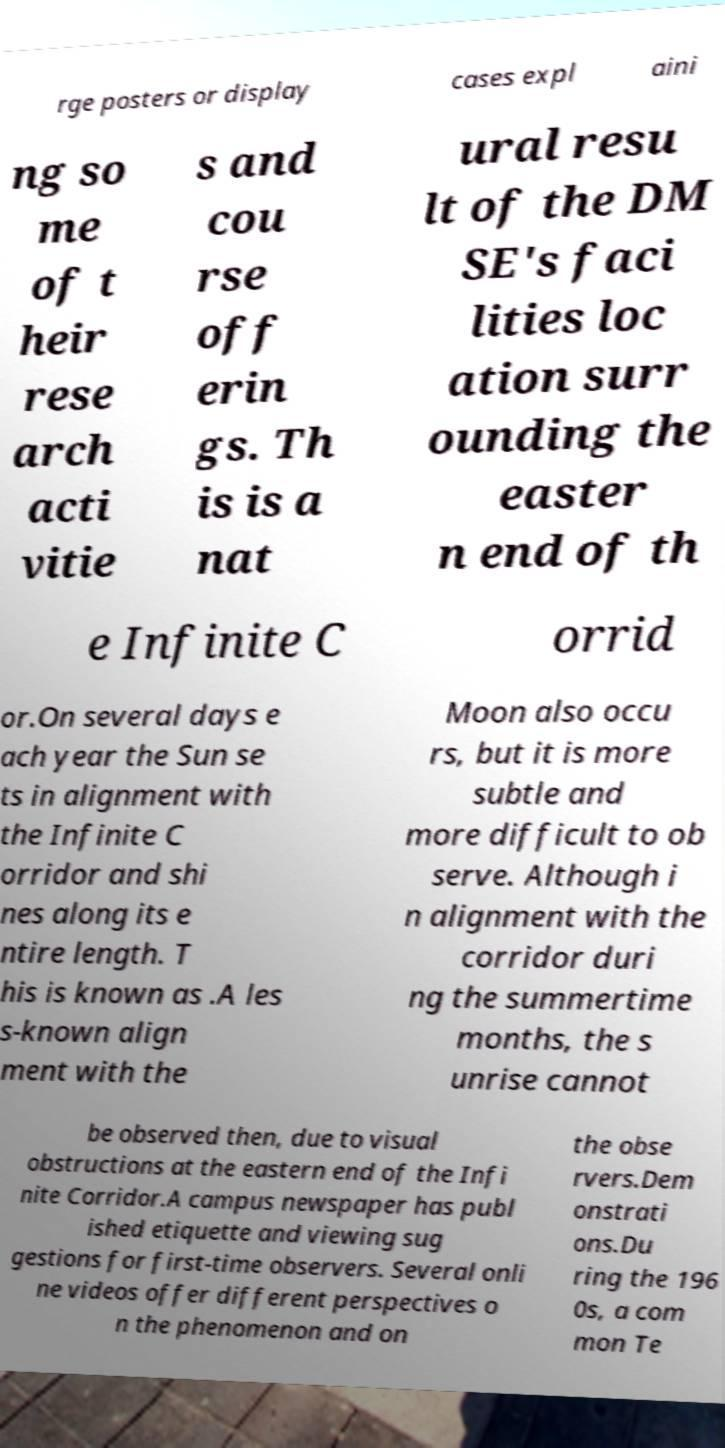Can you accurately transcribe the text from the provided image for me? rge posters or display cases expl aini ng so me of t heir rese arch acti vitie s and cou rse off erin gs. Th is is a nat ural resu lt of the DM SE's faci lities loc ation surr ounding the easter n end of th e Infinite C orrid or.On several days e ach year the Sun se ts in alignment with the Infinite C orridor and shi nes along its e ntire length. T his is known as .A les s-known align ment with the Moon also occu rs, but it is more subtle and more difficult to ob serve. Although i n alignment with the corridor duri ng the summertime months, the s unrise cannot be observed then, due to visual obstructions at the eastern end of the Infi nite Corridor.A campus newspaper has publ ished etiquette and viewing sug gestions for first-time observers. Several onli ne videos offer different perspectives o n the phenomenon and on the obse rvers.Dem onstrati ons.Du ring the 196 0s, a com mon Te 